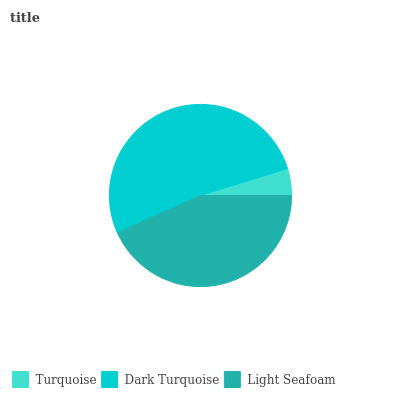Is Turquoise the minimum?
Answer yes or no. Yes. Is Dark Turquoise the maximum?
Answer yes or no. Yes. Is Light Seafoam the minimum?
Answer yes or no. No. Is Light Seafoam the maximum?
Answer yes or no. No. Is Dark Turquoise greater than Light Seafoam?
Answer yes or no. Yes. Is Light Seafoam less than Dark Turquoise?
Answer yes or no. Yes. Is Light Seafoam greater than Dark Turquoise?
Answer yes or no. No. Is Dark Turquoise less than Light Seafoam?
Answer yes or no. No. Is Light Seafoam the high median?
Answer yes or no. Yes. Is Light Seafoam the low median?
Answer yes or no. Yes. Is Dark Turquoise the high median?
Answer yes or no. No. Is Turquoise the low median?
Answer yes or no. No. 